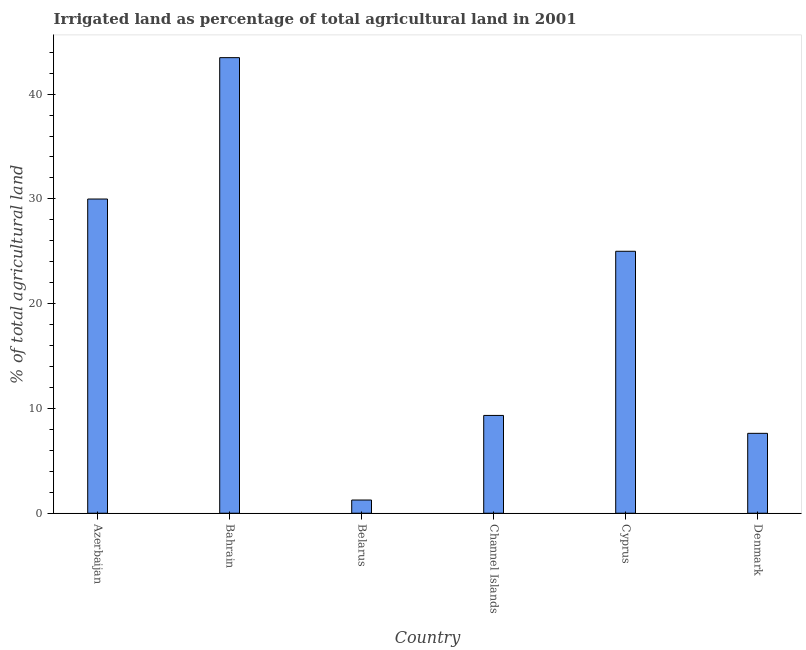Does the graph contain grids?
Your response must be concise. No. What is the title of the graph?
Provide a short and direct response. Irrigated land as percentage of total agricultural land in 2001. What is the label or title of the Y-axis?
Make the answer very short. % of total agricultural land. What is the percentage of agricultural irrigated land in Bahrain?
Your answer should be compact. 43.48. Across all countries, what is the maximum percentage of agricultural irrigated land?
Provide a short and direct response. 43.48. Across all countries, what is the minimum percentage of agricultural irrigated land?
Offer a very short reply. 1.26. In which country was the percentage of agricultural irrigated land maximum?
Your answer should be compact. Bahrain. In which country was the percentage of agricultural irrigated land minimum?
Keep it short and to the point. Belarus. What is the sum of the percentage of agricultural irrigated land?
Your answer should be compact. 116.68. What is the difference between the percentage of agricultural irrigated land in Bahrain and Cyprus?
Offer a terse response. 18.48. What is the average percentage of agricultural irrigated land per country?
Provide a succinct answer. 19.45. What is the median percentage of agricultural irrigated land?
Provide a succinct answer. 17.17. What is the ratio of the percentage of agricultural irrigated land in Bahrain to that in Belarus?
Provide a short and direct response. 34.51. Is the percentage of agricultural irrigated land in Bahrain less than that in Cyprus?
Keep it short and to the point. No. What is the difference between the highest and the second highest percentage of agricultural irrigated land?
Your response must be concise. 13.49. Is the sum of the percentage of agricultural irrigated land in Azerbaijan and Belarus greater than the maximum percentage of agricultural irrigated land across all countries?
Offer a very short reply. No. What is the difference between the highest and the lowest percentage of agricultural irrigated land?
Provide a short and direct response. 42.22. How many bars are there?
Your answer should be compact. 6. What is the difference between two consecutive major ticks on the Y-axis?
Ensure brevity in your answer.  10. Are the values on the major ticks of Y-axis written in scientific E-notation?
Make the answer very short. No. What is the % of total agricultural land of Azerbaijan?
Ensure brevity in your answer.  29.99. What is the % of total agricultural land in Bahrain?
Your response must be concise. 43.48. What is the % of total agricultural land of Belarus?
Give a very brief answer. 1.26. What is the % of total agricultural land in Channel Islands?
Give a very brief answer. 9.33. What is the % of total agricultural land in Denmark?
Ensure brevity in your answer.  7.62. What is the difference between the % of total agricultural land in Azerbaijan and Bahrain?
Give a very brief answer. -13.49. What is the difference between the % of total agricultural land in Azerbaijan and Belarus?
Offer a terse response. 28.73. What is the difference between the % of total agricultural land in Azerbaijan and Channel Islands?
Your response must be concise. 20.65. What is the difference between the % of total agricultural land in Azerbaijan and Cyprus?
Ensure brevity in your answer.  4.99. What is the difference between the % of total agricultural land in Azerbaijan and Denmark?
Make the answer very short. 22.36. What is the difference between the % of total agricultural land in Bahrain and Belarus?
Give a very brief answer. 42.22. What is the difference between the % of total agricultural land in Bahrain and Channel Islands?
Provide a short and direct response. 34.14. What is the difference between the % of total agricultural land in Bahrain and Cyprus?
Keep it short and to the point. 18.48. What is the difference between the % of total agricultural land in Bahrain and Denmark?
Provide a succinct answer. 35.85. What is the difference between the % of total agricultural land in Belarus and Channel Islands?
Keep it short and to the point. -8.07. What is the difference between the % of total agricultural land in Belarus and Cyprus?
Provide a short and direct response. -23.74. What is the difference between the % of total agricultural land in Belarus and Denmark?
Provide a short and direct response. -6.36. What is the difference between the % of total agricultural land in Channel Islands and Cyprus?
Offer a very short reply. -15.67. What is the difference between the % of total agricultural land in Channel Islands and Denmark?
Offer a terse response. 1.71. What is the difference between the % of total agricultural land in Cyprus and Denmark?
Make the answer very short. 17.38. What is the ratio of the % of total agricultural land in Azerbaijan to that in Bahrain?
Offer a very short reply. 0.69. What is the ratio of the % of total agricultural land in Azerbaijan to that in Belarus?
Your response must be concise. 23.8. What is the ratio of the % of total agricultural land in Azerbaijan to that in Channel Islands?
Offer a very short reply. 3.21. What is the ratio of the % of total agricultural land in Azerbaijan to that in Cyprus?
Your response must be concise. 1.2. What is the ratio of the % of total agricultural land in Azerbaijan to that in Denmark?
Your answer should be compact. 3.93. What is the ratio of the % of total agricultural land in Bahrain to that in Belarus?
Provide a short and direct response. 34.51. What is the ratio of the % of total agricultural land in Bahrain to that in Channel Islands?
Make the answer very short. 4.66. What is the ratio of the % of total agricultural land in Bahrain to that in Cyprus?
Ensure brevity in your answer.  1.74. What is the ratio of the % of total agricultural land in Bahrain to that in Denmark?
Provide a succinct answer. 5.7. What is the ratio of the % of total agricultural land in Belarus to that in Channel Islands?
Keep it short and to the point. 0.14. What is the ratio of the % of total agricultural land in Belarus to that in Cyprus?
Your response must be concise. 0.05. What is the ratio of the % of total agricultural land in Belarus to that in Denmark?
Your answer should be very brief. 0.17. What is the ratio of the % of total agricultural land in Channel Islands to that in Cyprus?
Keep it short and to the point. 0.37. What is the ratio of the % of total agricultural land in Channel Islands to that in Denmark?
Give a very brief answer. 1.22. What is the ratio of the % of total agricultural land in Cyprus to that in Denmark?
Provide a short and direct response. 3.28. 